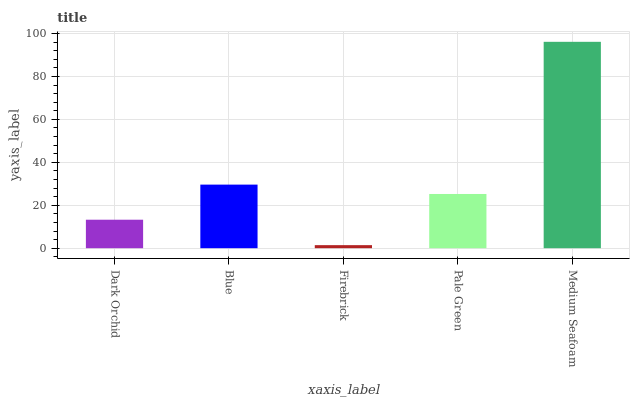Is Medium Seafoam the maximum?
Answer yes or no. Yes. Is Blue the minimum?
Answer yes or no. No. Is Blue the maximum?
Answer yes or no. No. Is Blue greater than Dark Orchid?
Answer yes or no. Yes. Is Dark Orchid less than Blue?
Answer yes or no. Yes. Is Dark Orchid greater than Blue?
Answer yes or no. No. Is Blue less than Dark Orchid?
Answer yes or no. No. Is Pale Green the high median?
Answer yes or no. Yes. Is Pale Green the low median?
Answer yes or no. Yes. Is Firebrick the high median?
Answer yes or no. No. Is Firebrick the low median?
Answer yes or no. No. 